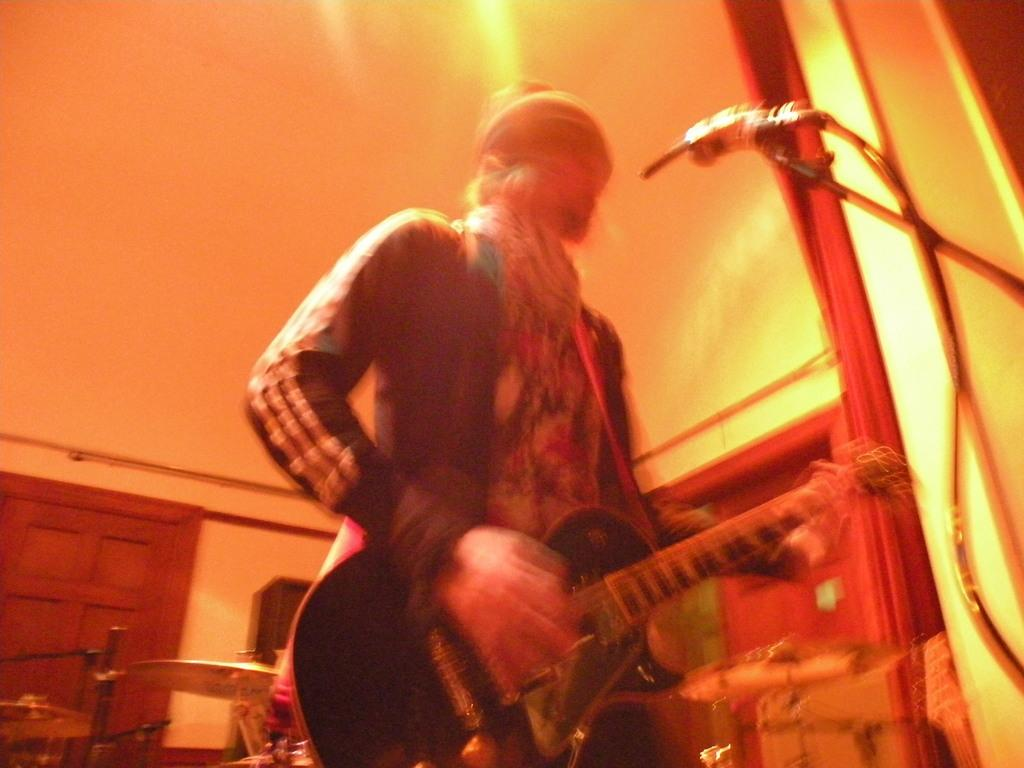What is the person in the image doing? The person is standing and holding a guitar. What else can be seen in the image related to music? There are musical instruments in the background and a microphone with a stand in the image. What is visible in the background of the image? There is a wall in the background. How many sisters are playing the guitar in the image? There are no sisters present in the image, and only one person is holding a guitar. What type of boats are visible in the image? There are no boats visible in the image. 